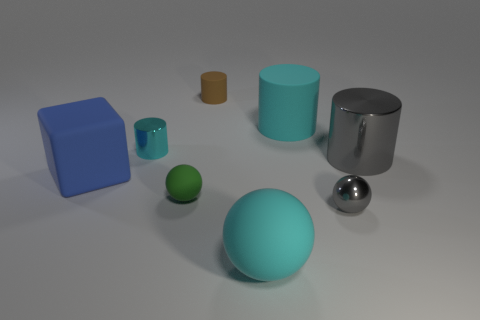Subtract all cyan cylinders. How many were subtracted if there are1cyan cylinders left? 1 Subtract 1 cylinders. How many cylinders are left? 3 Add 1 big gray metallic cylinders. How many objects exist? 9 Subtract all balls. How many objects are left? 5 Subtract all large blue matte cubes. Subtract all gray metallic spheres. How many objects are left? 6 Add 2 tiny spheres. How many tiny spheres are left? 4 Add 8 small yellow things. How many small yellow things exist? 8 Subtract 0 yellow cylinders. How many objects are left? 8 